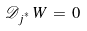<formula> <loc_0><loc_0><loc_500><loc_500>\mathcal { D } _ { j ^ { ^ { * } } } \, W \, = \, 0</formula> 